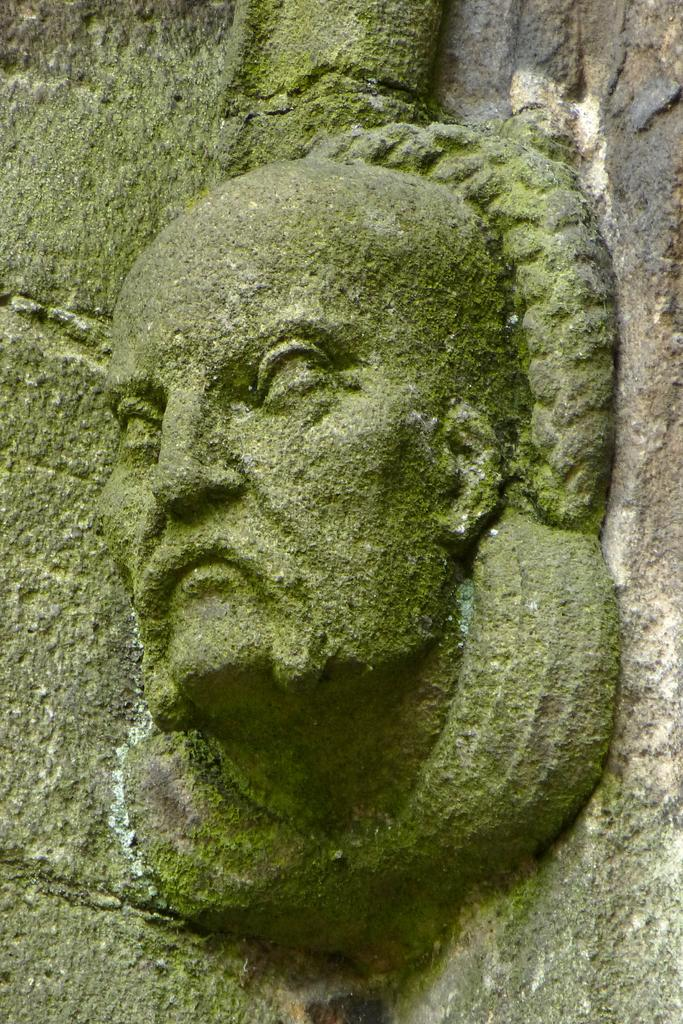What is the main subject of the image? The main subject of the image is a sculpture of a man's face. Where is the sculpture located in the image? The sculpture is attached to a wall. What type of plant is growing in the jail cell in the image? There is no jail cell or plant present in the image; it features a sculpture of a man's face attached to a wall. 